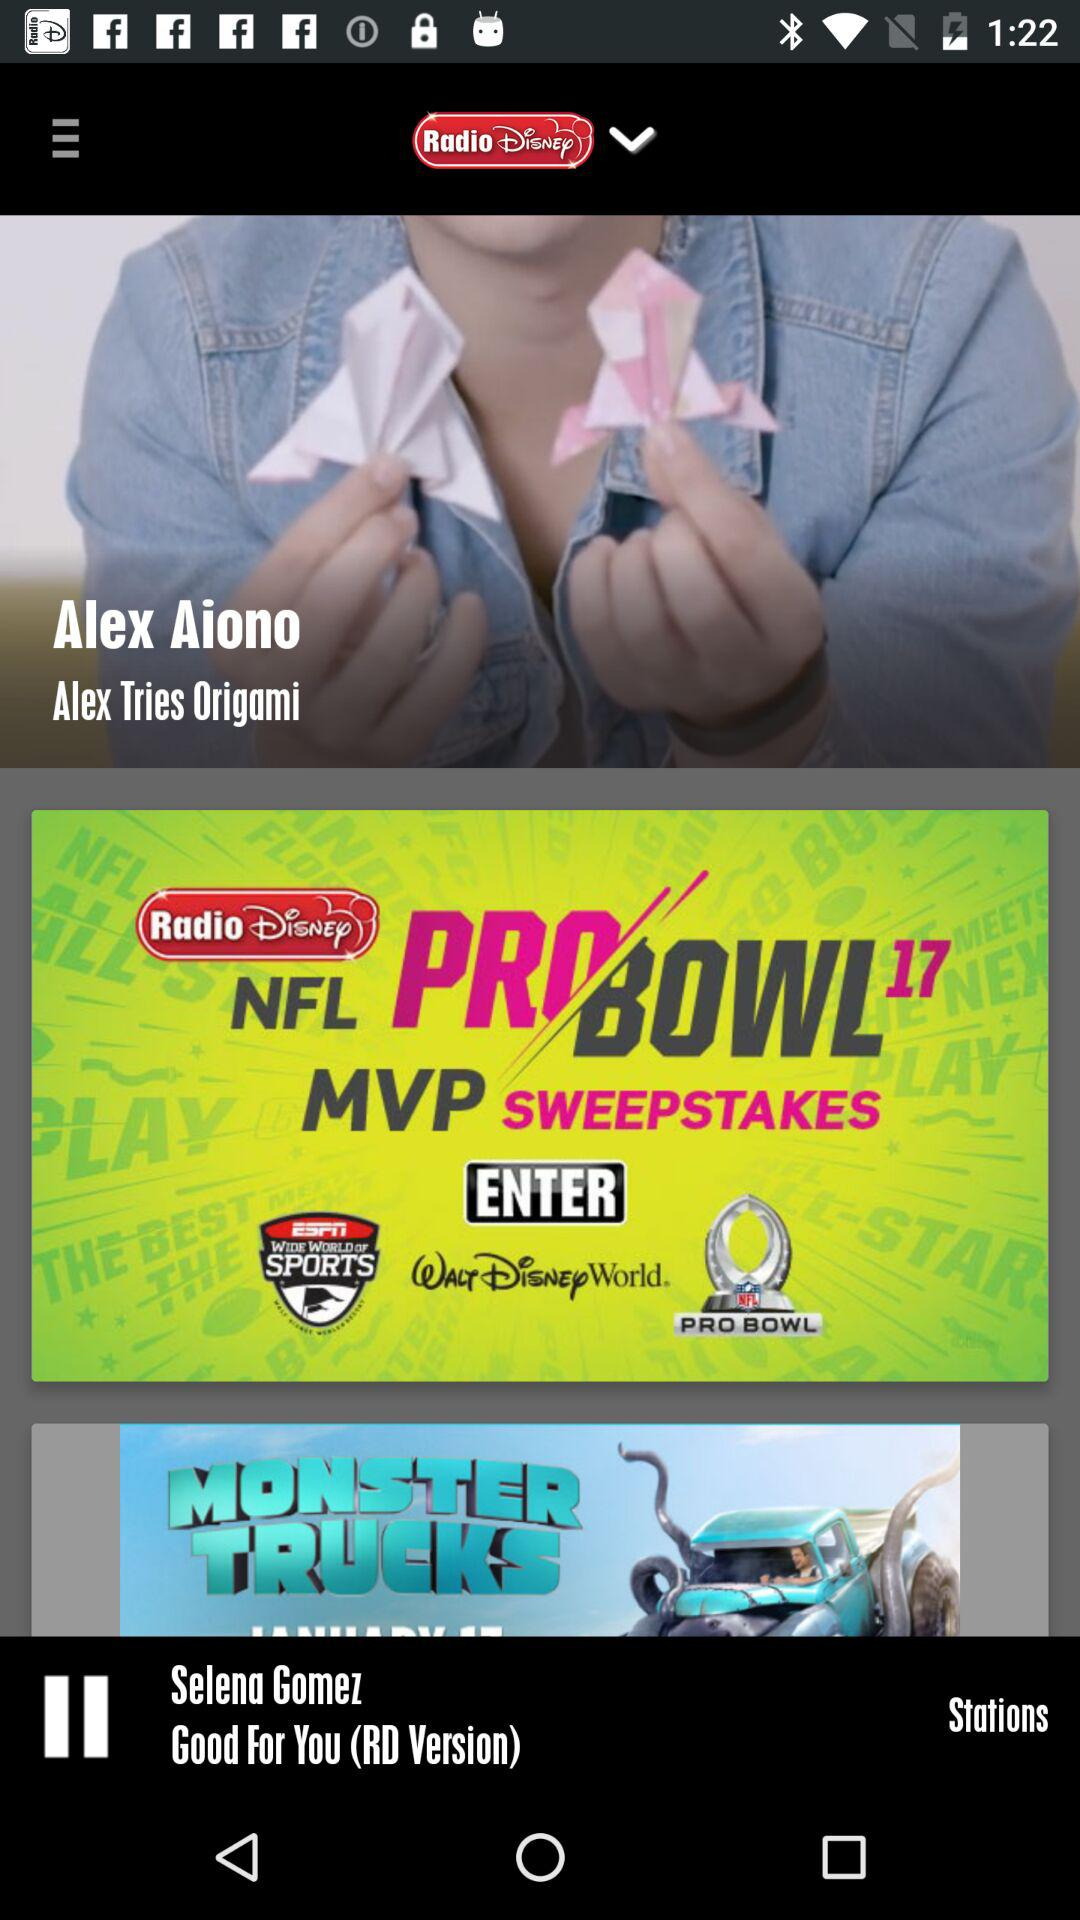Which song is being played? The song is "Good For You (RD Version)". 